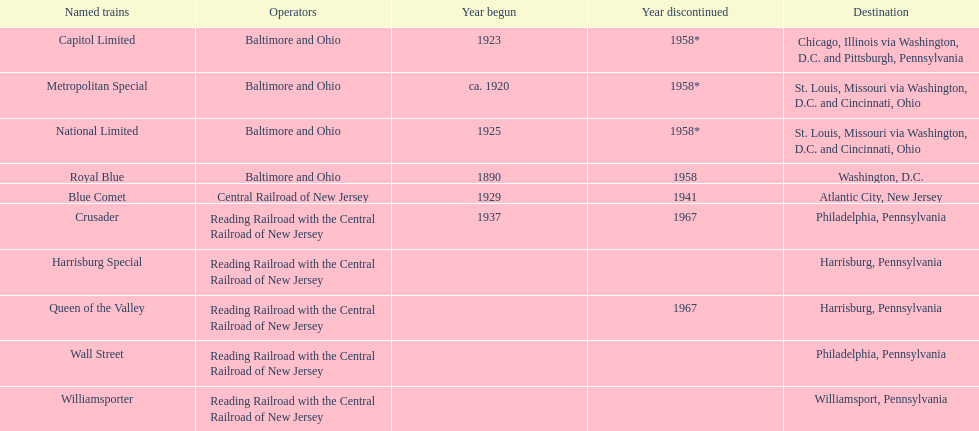What destination is at the top of the list? Chicago, Illinois via Washington, D.C. and Pittsburgh, Pennsylvania. 